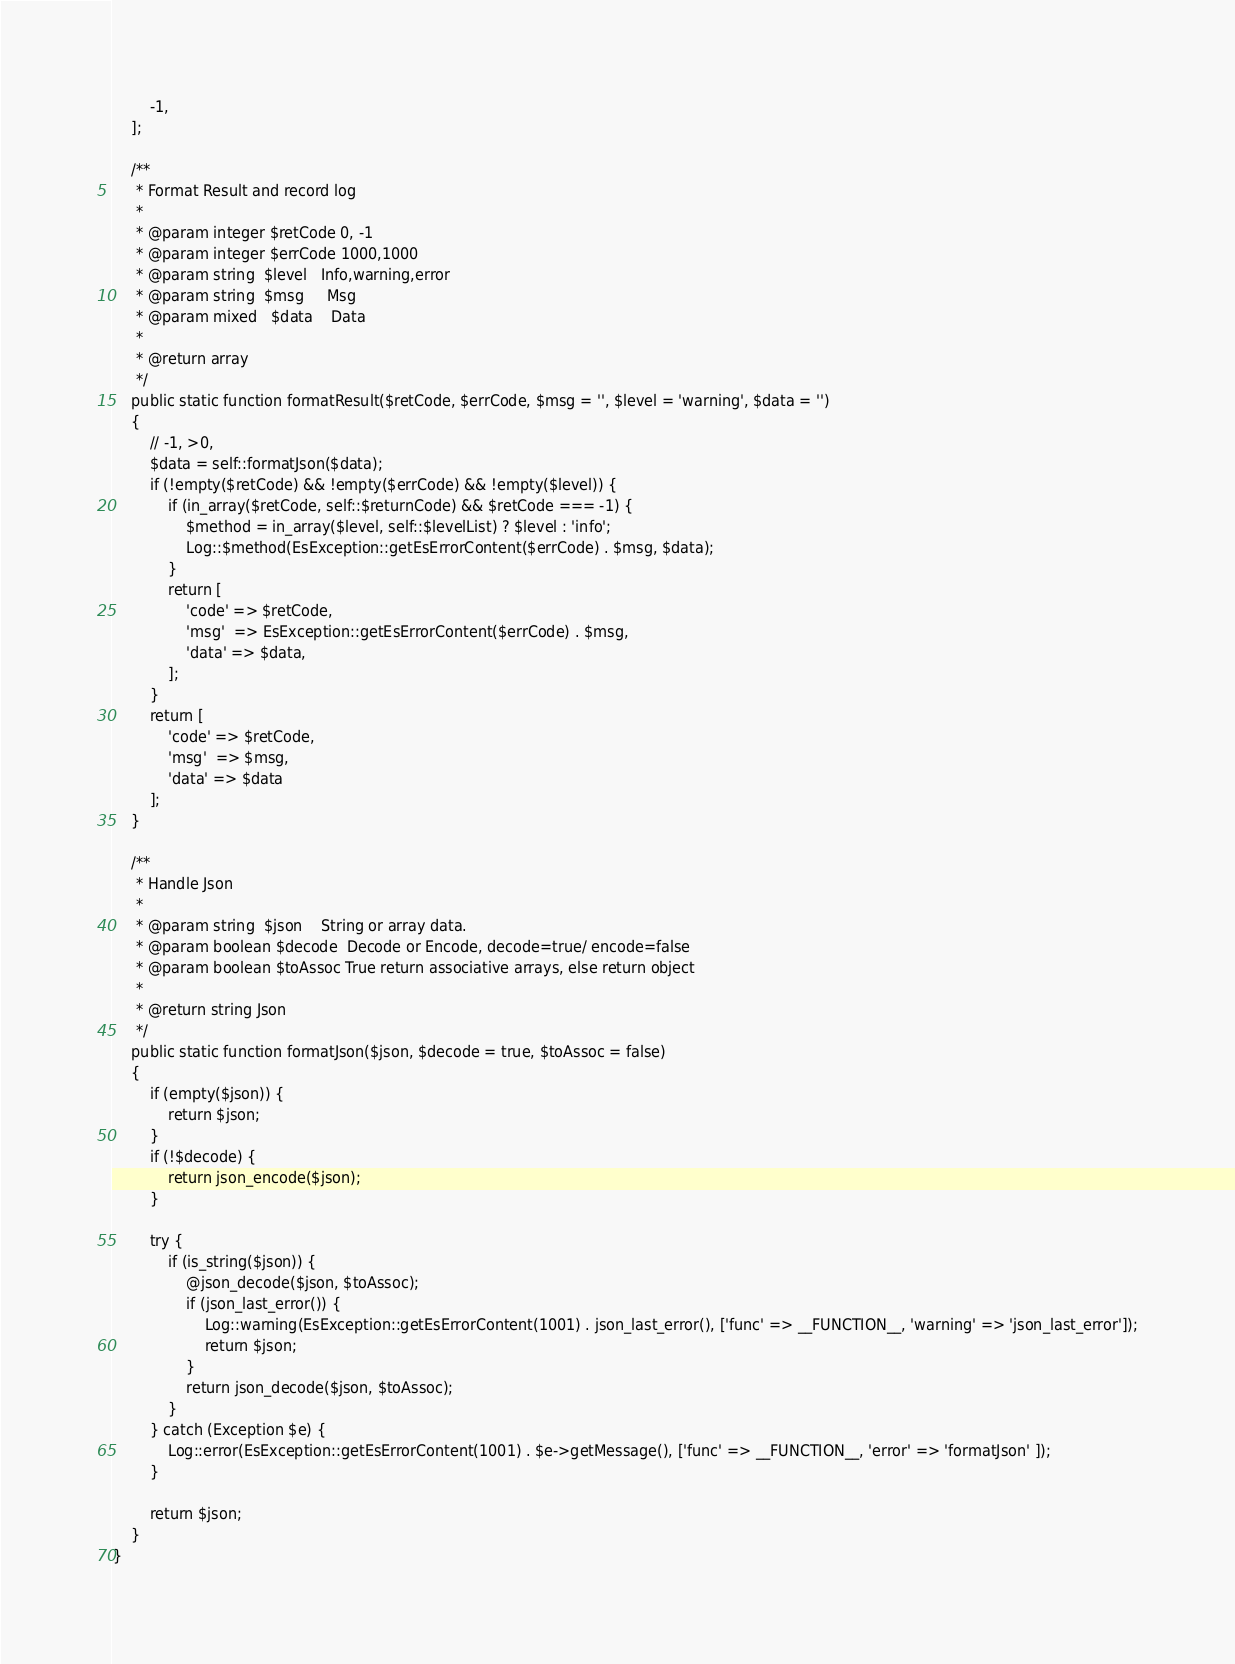Convert code to text. <code><loc_0><loc_0><loc_500><loc_500><_PHP_>        -1,
    ];

    /**
     * Format Result and record log
     *
     * @param integer $retCode 0, -1
     * @param integer $errCode 1000,1000
     * @param string  $level   Info,warning,error
     * @param string  $msg     Msg
     * @param mixed   $data    Data
     *
     * @return array
     */
    public static function formatResult($retCode, $errCode, $msg = '', $level = 'warning', $data = '')
    {
        // -1, >0,
        $data = self::formatJson($data);
        if (!empty($retCode) && !empty($errCode) && !empty($level)) {
            if (in_array($retCode, self::$returnCode) && $retCode === -1) {
                $method = in_array($level, self::$levelList) ? $level : 'info';
                Log::$method(EsException::getEsErrorContent($errCode) . $msg, $data);
            }
            return [
                'code' => $retCode,
                'msg'  => EsException::getEsErrorContent($errCode) . $msg,
                'data' => $data,
            ];
        }
        return [
            'code' => $retCode,
            'msg'  => $msg,
            'data' => $data
        ];
    }

    /**
     * Handle Json
     *
     * @param string  $json    String or array data.
     * @param boolean $decode  Decode or Encode, decode=true/ encode=false
     * @param boolean $toAssoc True return associative arrays, else return object
     *
     * @return string Json
     */
    public static function formatJson($json, $decode = true, $toAssoc = false)
    {
        if (empty($json)) {
            return $json;
        }
        if (!$decode) {
            return json_encode($json);
        }

        try {
            if (is_string($json)) {
                @json_decode($json, $toAssoc);
                if (json_last_error()) {
                    Log::warning(EsException::getEsErrorContent(1001) . json_last_error(), ['func' => __FUNCTION__, 'warning' => 'json_last_error']);
                    return $json;
                }
                return json_decode($json, $toAssoc);
            }
        } catch (Exception $e) {
            Log::error(EsException::getEsErrorContent(1001) . $e->getMessage(), ['func' => __FUNCTION__, 'error' => 'formatJson' ]);
        }

        return $json;
    }
}
</code> 